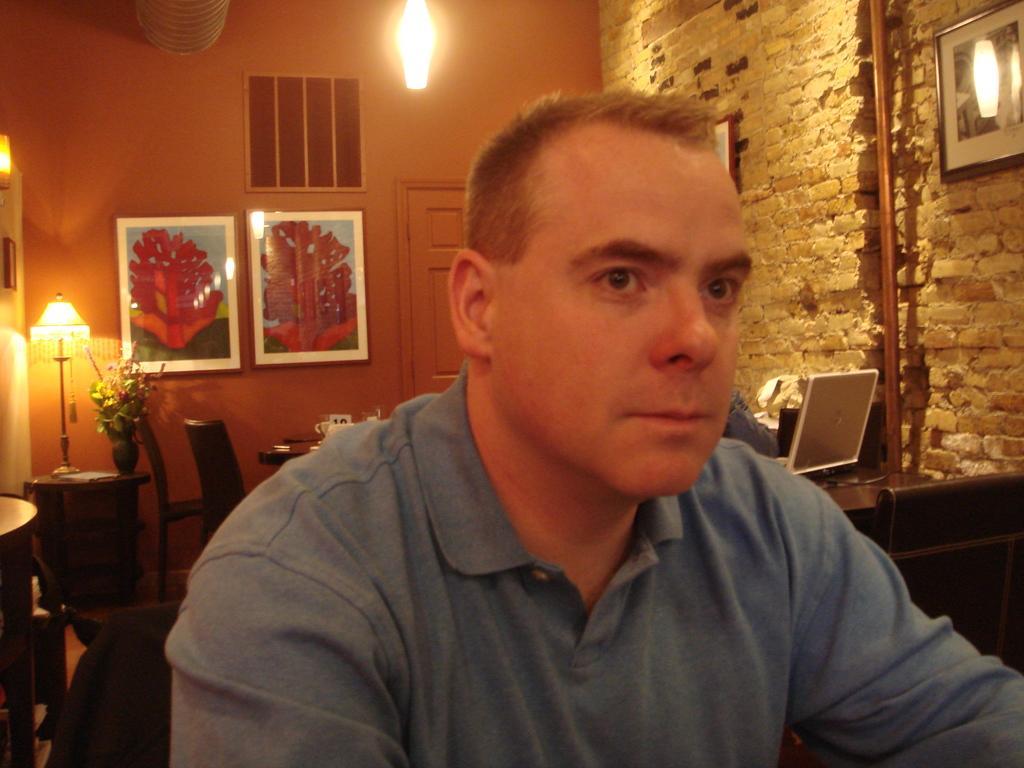Please provide a concise description of this image. In this picture we can see man sitting and in the background we can see wall with frames, door, light, chair, table, flower vase, lamp, laptop, rod. 